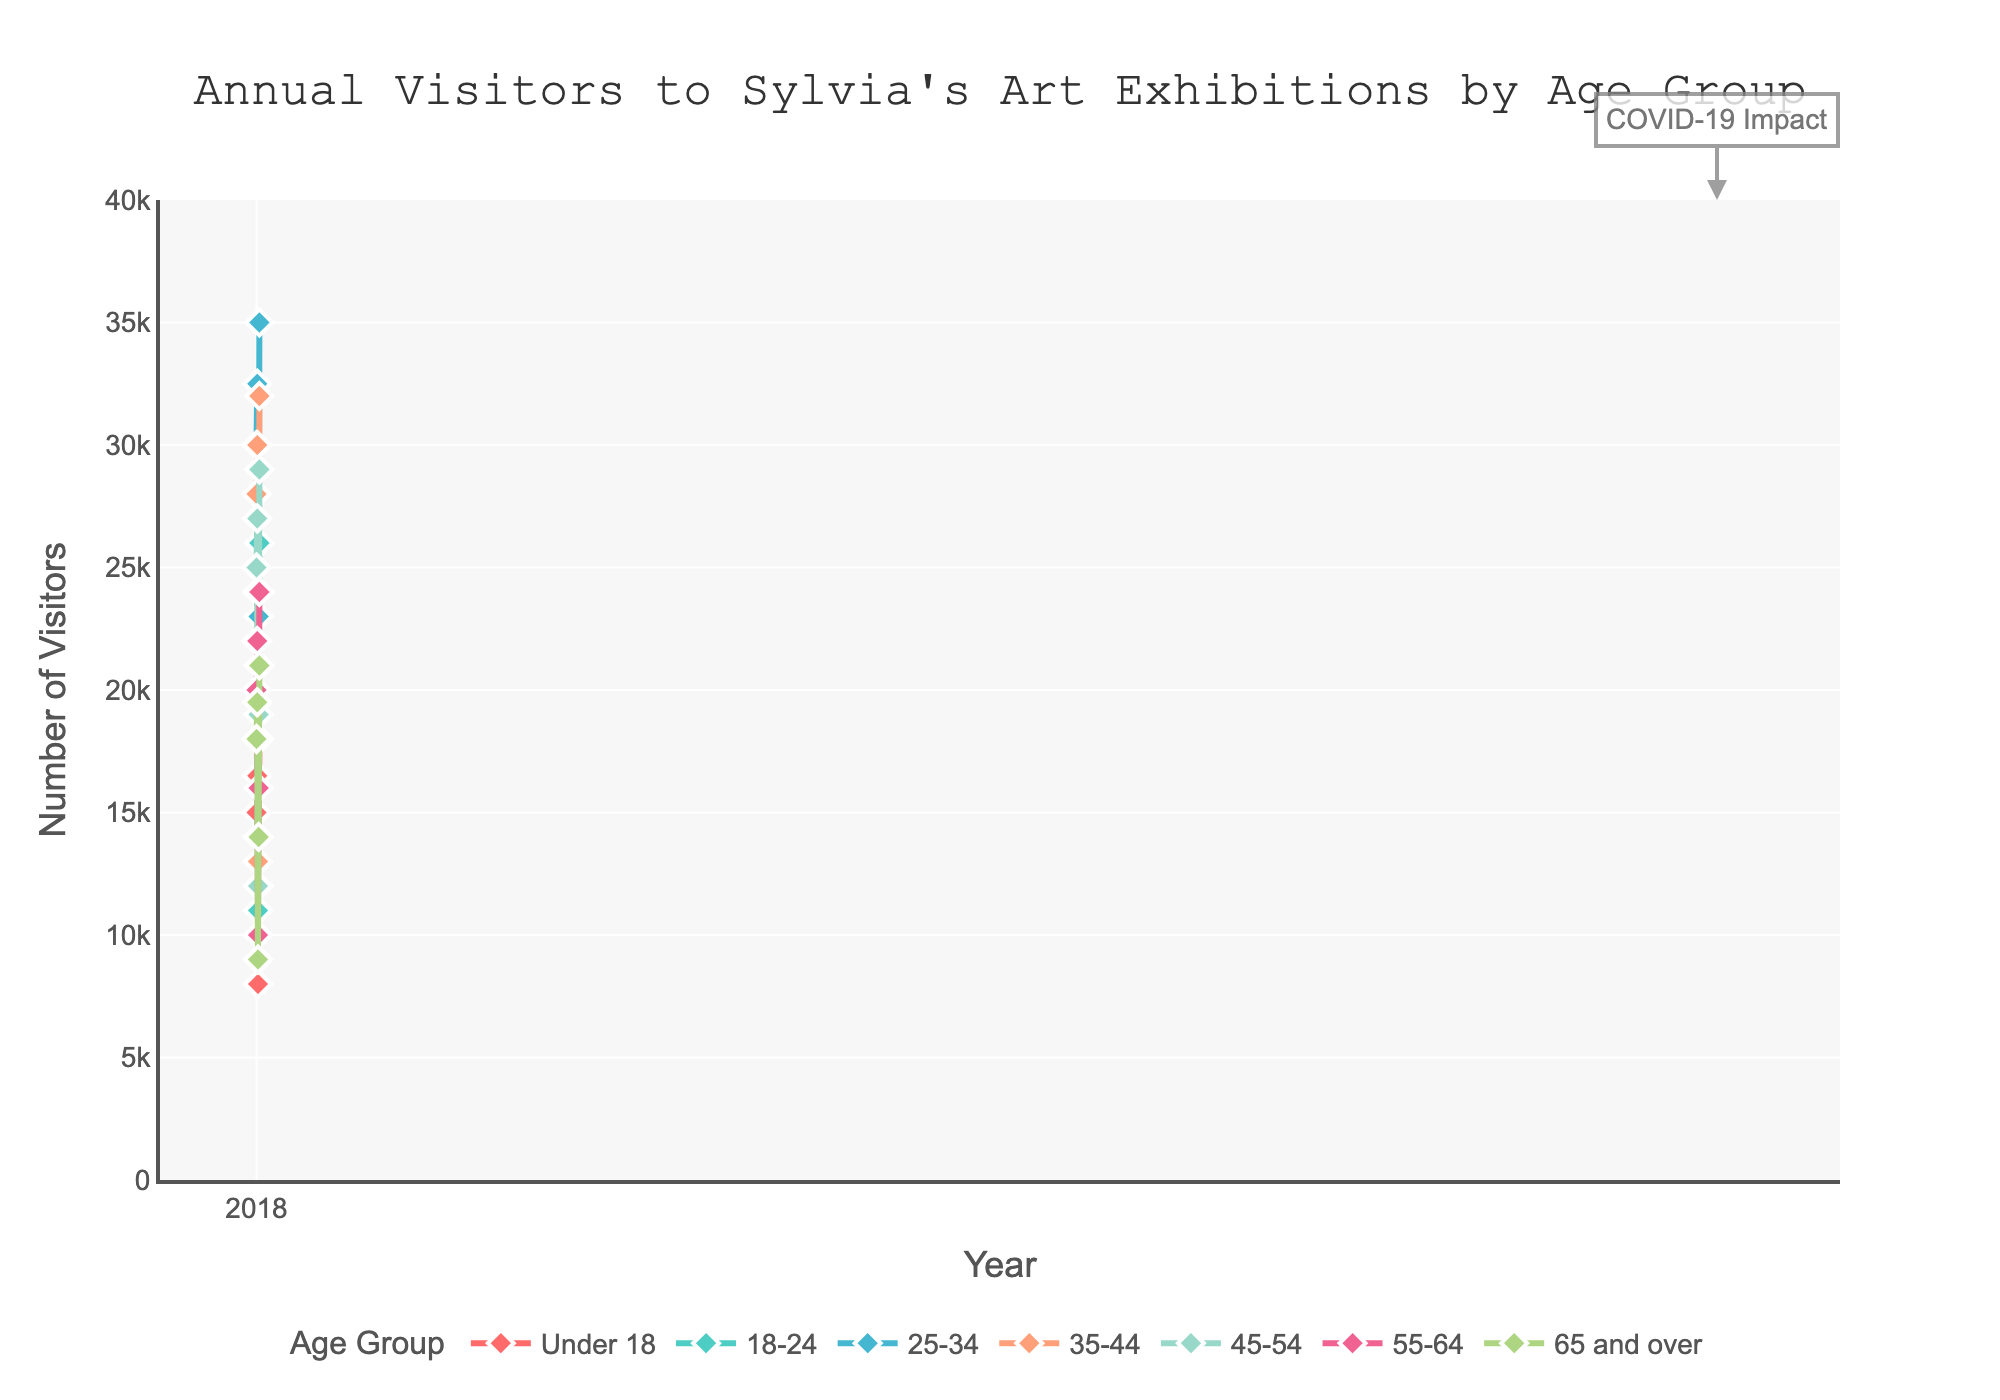Which age group saw the highest number of visitors in 2022? Look at the lines and markers for the year 2022 and identify which age group has the highest point. The 25-34 age group has the highest number of visitors in 2022.
Answer: 25-34 Which age group experienced the largest drop in visitors between 2019 and 2020? Compare the height of the markers between 2019 and 2020 for each age group. The 25-34 age group saw the biggest decline in visitors from 32,500 in 2019 to 14,000 in 2020.
Answer: 25-34 What is the average number of visitors across all age groups in 2018? Sum the number of visitors for each age group in 2018 and divide by the number of age groups. (15,000 + 22,000 + 30,000 + 28,000 + 25,000 + 20,000 + 18,000) / 7 = 158,000 / 7 ≈ 22,571
Answer: 22,571 Which two age groups had an equal number of visitors in any given year? Look for matching points on the plot for each year where two lines converge. In 2020, the under 18 and 65 and over age groups both had 9,000 visitors.
Answer: Under 18 and 65 and over What is the total number of visitors in 2021 for the 35-44 and 55-64 age groups combined? Add the visitor counts for the 35-44 and 55-64 age groups in the year 2021. 21,000 (35-44) + 16,000 (55-64) = 37,000
Answer: 37,000 Which age group showed the most consistent visitor numbers, without large fluctuations, across the years? Examine the plot and identify the line with the least variation in height over the years. The 65 and over age group's line is relatively smooth with smaller fluctuations compared to others.
Answer: 65 and over How many more visitors did the 18-24 age group have compared to the under 18 group in 2022? Subtract the number of visitors for the under 18 group from the 18-24 group in 2022. 26,000 (18-24) - 18,000 (Under 18) = 8,000
Answer: 8,000 What was the combined total of visitors for all age groups in 2020? Sum the number of visitors for each age group in 2020. 8,000 + 11,000 + 14,000 + 13,000 + 12,000 + 10,000 + 9,000 = 77,000
Answer: 77,000 Which age group had the second highest number of visitors in 2019? Compare the second highest points for 2019. The second highest number of visitors in 2019 belongs to the 25-34 age group with 32,500 visitors, just below the 35-44 age group's 30,000 visitors.
Answer: 25-34 